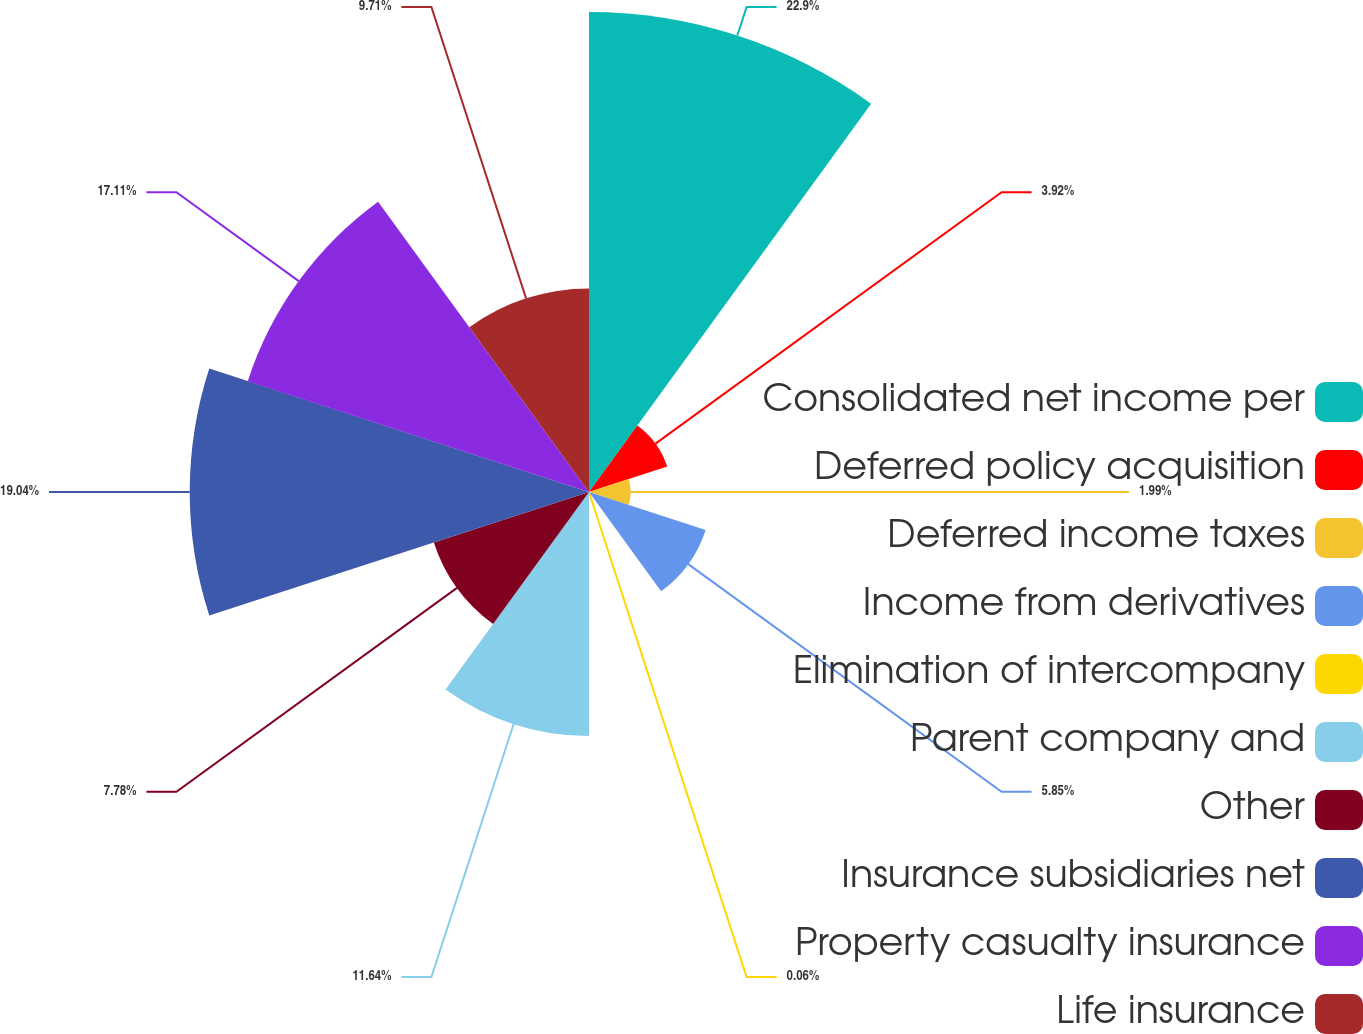Convert chart. <chart><loc_0><loc_0><loc_500><loc_500><pie_chart><fcel>Consolidated net income per<fcel>Deferred policy acquisition<fcel>Deferred income taxes<fcel>Income from derivatives<fcel>Elimination of intercompany<fcel>Parent company and<fcel>Other<fcel>Insurance subsidiaries net<fcel>Property casualty insurance<fcel>Life insurance<nl><fcel>22.89%<fcel>3.92%<fcel>1.99%<fcel>5.85%<fcel>0.06%<fcel>11.64%<fcel>7.78%<fcel>19.04%<fcel>17.11%<fcel>9.71%<nl></chart> 